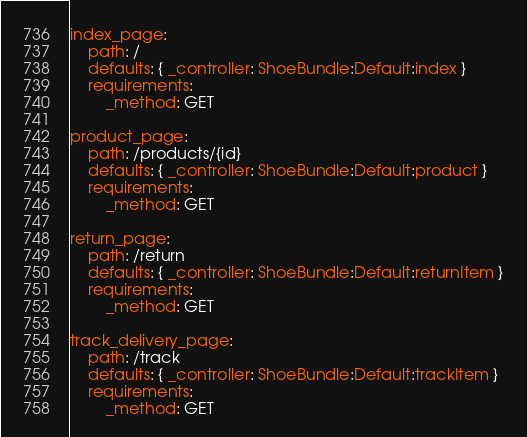Convert code to text. <code><loc_0><loc_0><loc_500><loc_500><_YAML_>index_page:
    path: /
    defaults: { _controller: ShoeBundle:Default:index }
    requirements:
        _method: GET

product_page:
    path: /products/{id}
    defaults: { _controller: ShoeBundle:Default:product }
    requirements:
        _method: GET

return_page:
    path: /return
    defaults: { _controller: ShoeBundle:Default:returnItem }
    requirements:
        _method: GET

track_delivery_page:
    path: /track
    defaults: { _controller: ShoeBundle:Default:trackItem }
    requirements:
        _method: GET</code> 